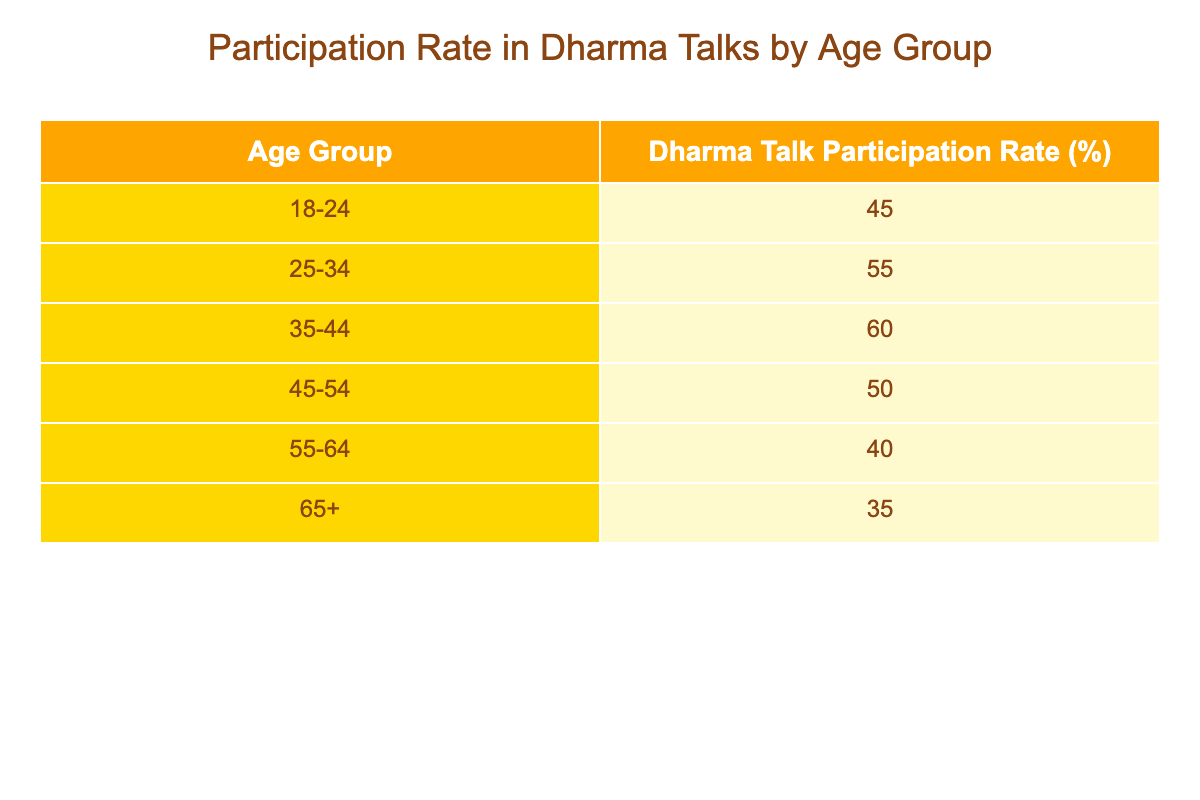What is the Dharma Talk Participation Rate for the age group 25-34? According to the table, the Dharma Talk Participation Rate for the age group 25-34 is listed directly in the corresponding row.
Answer: 55 Which age group has the highest Dharma Talk Participation Rate? By examining the values in the table, the age group 35-44 shows the highest participation rate at 60%.
Answer: 35-44 What is the difference in participation rates between the age groups 18-24 and 65+? The participation rate for 18-24 is 45% and for 65+ is 35%. The difference is calculated by subtracting 35 from 45, which gives us 10%.
Answer: 10 Is the Dharma Talk Participation Rate for those aged 55-64 greater than for those aged 45-54? The rate for 55-64 is 40% while for 45-54 it is 50%. Since 40% is not greater than 50%, the answer is no.
Answer: No What is the average Dharma Talk Participation Rate for the age groups 45-54 and 55-64? The participation rates are 50% for 45-54 and 40% for 55-64. To find the average, sum these two rates (50 + 40 = 90) and divide by 2, which gives us an average of 45%.
Answer: 45 How many age groups have a participation rate that is 50% or higher? The table indicates participation rates of 55% (25-34) and 60% (35-44), which are both 50% or higher. Therefore, there are three groups: 25-34, 35-44, and 45-54.
Answer: 3 What is the total Dharma Talk Participation Rate for all age groups combined? This requires adding up all participation rates from the table: 45 + 55 + 60 + 50 + 40 + 35 = 285. So the total is 285%.
Answer: 285 Is there any age group with a participation rate lower than 40%? Checking the values, the participation rate for 65+ is 35%, which is indeed lower than 40%. Therefore, the answer is yes.
Answer: Yes 